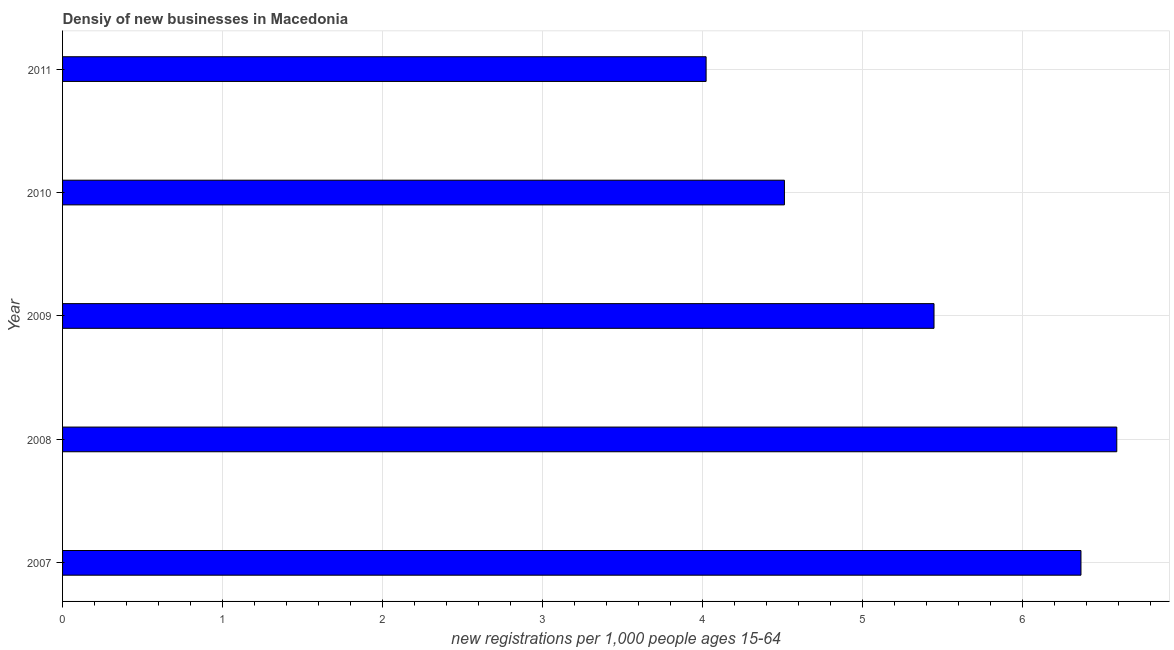Does the graph contain grids?
Offer a very short reply. Yes. What is the title of the graph?
Keep it short and to the point. Densiy of new businesses in Macedonia. What is the label or title of the X-axis?
Your answer should be very brief. New registrations per 1,0 people ages 15-64. What is the label or title of the Y-axis?
Offer a very short reply. Year. What is the density of new business in 2010?
Your answer should be compact. 4.51. Across all years, what is the maximum density of new business?
Provide a short and direct response. 6.59. Across all years, what is the minimum density of new business?
Your response must be concise. 4.02. What is the sum of the density of new business?
Your response must be concise. 26.95. What is the difference between the density of new business in 2010 and 2011?
Ensure brevity in your answer.  0.49. What is the average density of new business per year?
Provide a succinct answer. 5.39. What is the median density of new business?
Your answer should be compact. 5.45. In how many years, is the density of new business greater than 3.6 ?
Provide a short and direct response. 5. What is the ratio of the density of new business in 2008 to that in 2010?
Your answer should be very brief. 1.46. Is the density of new business in 2008 less than that in 2010?
Give a very brief answer. No. What is the difference between the highest and the second highest density of new business?
Give a very brief answer. 0.22. Is the sum of the density of new business in 2007 and 2010 greater than the maximum density of new business across all years?
Your answer should be very brief. Yes. What is the difference between the highest and the lowest density of new business?
Your answer should be very brief. 2.57. In how many years, is the density of new business greater than the average density of new business taken over all years?
Provide a short and direct response. 3. How many bars are there?
Your answer should be compact. 5. Are the values on the major ticks of X-axis written in scientific E-notation?
Give a very brief answer. No. What is the new registrations per 1,000 people ages 15-64 of 2007?
Your answer should be very brief. 6.37. What is the new registrations per 1,000 people ages 15-64 in 2008?
Keep it short and to the point. 6.59. What is the new registrations per 1,000 people ages 15-64 of 2009?
Make the answer very short. 5.45. What is the new registrations per 1,000 people ages 15-64 of 2010?
Your answer should be very brief. 4.51. What is the new registrations per 1,000 people ages 15-64 of 2011?
Ensure brevity in your answer.  4.02. What is the difference between the new registrations per 1,000 people ages 15-64 in 2007 and 2008?
Ensure brevity in your answer.  -0.22. What is the difference between the new registrations per 1,000 people ages 15-64 in 2007 and 2009?
Your response must be concise. 0.92. What is the difference between the new registrations per 1,000 people ages 15-64 in 2007 and 2010?
Your response must be concise. 1.85. What is the difference between the new registrations per 1,000 people ages 15-64 in 2007 and 2011?
Ensure brevity in your answer.  2.34. What is the difference between the new registrations per 1,000 people ages 15-64 in 2008 and 2009?
Keep it short and to the point. 1.14. What is the difference between the new registrations per 1,000 people ages 15-64 in 2008 and 2010?
Ensure brevity in your answer.  2.08. What is the difference between the new registrations per 1,000 people ages 15-64 in 2008 and 2011?
Keep it short and to the point. 2.57. What is the difference between the new registrations per 1,000 people ages 15-64 in 2009 and 2010?
Ensure brevity in your answer.  0.94. What is the difference between the new registrations per 1,000 people ages 15-64 in 2009 and 2011?
Offer a terse response. 1.43. What is the difference between the new registrations per 1,000 people ages 15-64 in 2010 and 2011?
Provide a short and direct response. 0.49. What is the ratio of the new registrations per 1,000 people ages 15-64 in 2007 to that in 2008?
Provide a short and direct response. 0.97. What is the ratio of the new registrations per 1,000 people ages 15-64 in 2007 to that in 2009?
Your answer should be very brief. 1.17. What is the ratio of the new registrations per 1,000 people ages 15-64 in 2007 to that in 2010?
Make the answer very short. 1.41. What is the ratio of the new registrations per 1,000 people ages 15-64 in 2007 to that in 2011?
Give a very brief answer. 1.58. What is the ratio of the new registrations per 1,000 people ages 15-64 in 2008 to that in 2009?
Offer a very short reply. 1.21. What is the ratio of the new registrations per 1,000 people ages 15-64 in 2008 to that in 2010?
Make the answer very short. 1.46. What is the ratio of the new registrations per 1,000 people ages 15-64 in 2008 to that in 2011?
Give a very brief answer. 1.64. What is the ratio of the new registrations per 1,000 people ages 15-64 in 2009 to that in 2010?
Make the answer very short. 1.21. What is the ratio of the new registrations per 1,000 people ages 15-64 in 2009 to that in 2011?
Give a very brief answer. 1.35. What is the ratio of the new registrations per 1,000 people ages 15-64 in 2010 to that in 2011?
Offer a terse response. 1.12. 